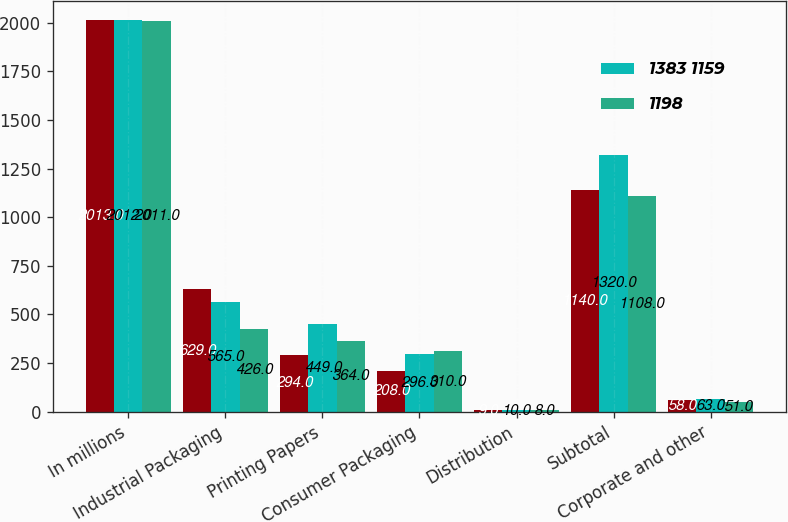Convert chart. <chart><loc_0><loc_0><loc_500><loc_500><stacked_bar_chart><ecel><fcel>In millions<fcel>Industrial Packaging<fcel>Printing Papers<fcel>Consumer Packaging<fcel>Distribution<fcel>Subtotal<fcel>Corporate and other<nl><fcel>nan<fcel>2013<fcel>629<fcel>294<fcel>208<fcel>9<fcel>1140<fcel>58<nl><fcel>1383 1159<fcel>2012<fcel>565<fcel>449<fcel>296<fcel>10<fcel>1320<fcel>63<nl><fcel>1198<fcel>2011<fcel>426<fcel>364<fcel>310<fcel>8<fcel>1108<fcel>51<nl></chart> 